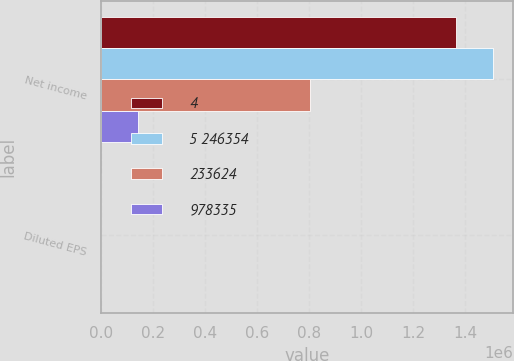Convert chart. <chart><loc_0><loc_0><loc_500><loc_500><stacked_bar_chart><ecel><fcel>Net income<fcel>Diluted EPS<nl><fcel>4<fcel>1.36301e+06<fcel>3.65<nl><fcel>5 246354<fcel>1.50698e+06<fcel>4<nl><fcel>233624<fcel>805379<fcel>2.29<nl><fcel>978335<fcel>143969<fcel>0.35<nl></chart> 